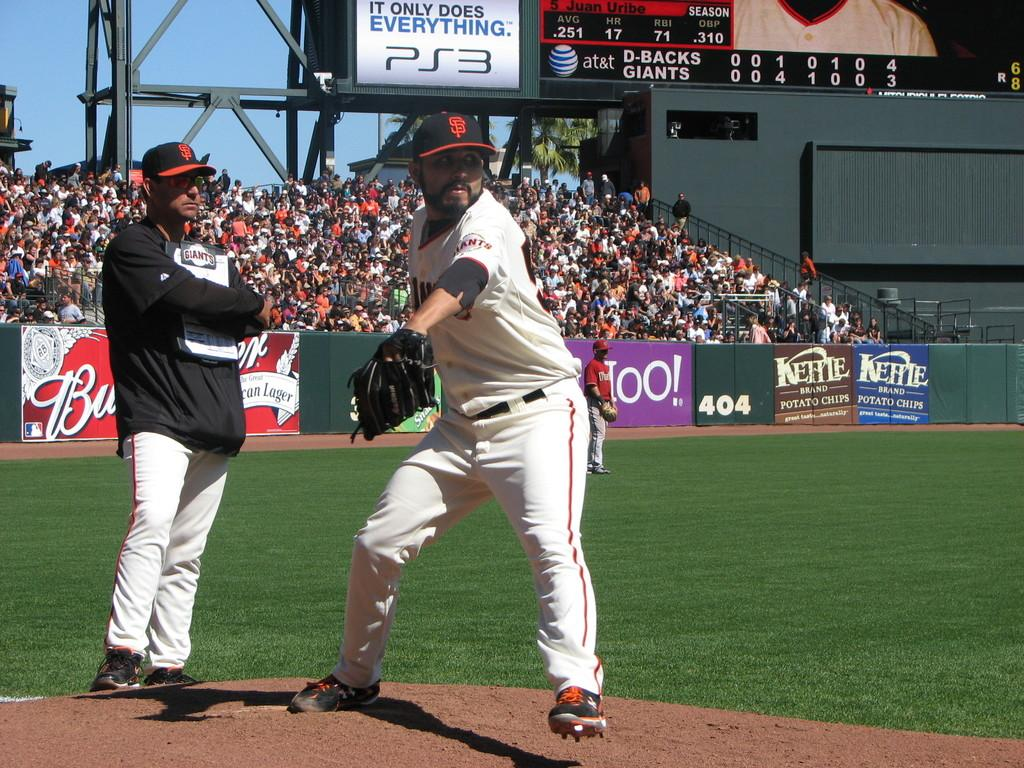Provide a one-sentence caption for the provided image. A player from the San Francisco Giants is standing on a baseball field. 